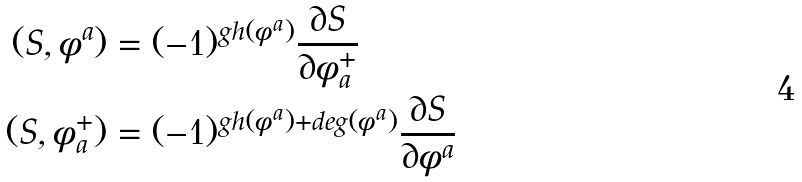Convert formula to latex. <formula><loc_0><loc_0><loc_500><loc_500>( S , \phi ^ { a } ) & = ( - 1 ) ^ { g h ( \phi ^ { a } ) } \frac { \partial S } { \partial \phi ^ { + } _ { a } } \\ ( S , \phi ^ { + } _ { a } ) & = ( - 1 ) ^ { g h ( \phi ^ { a } ) + d e g ( \phi ^ { a } ) } \frac { \partial S } { \partial \phi ^ { a } }</formula> 